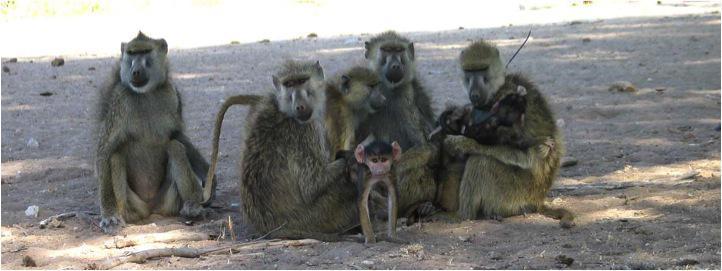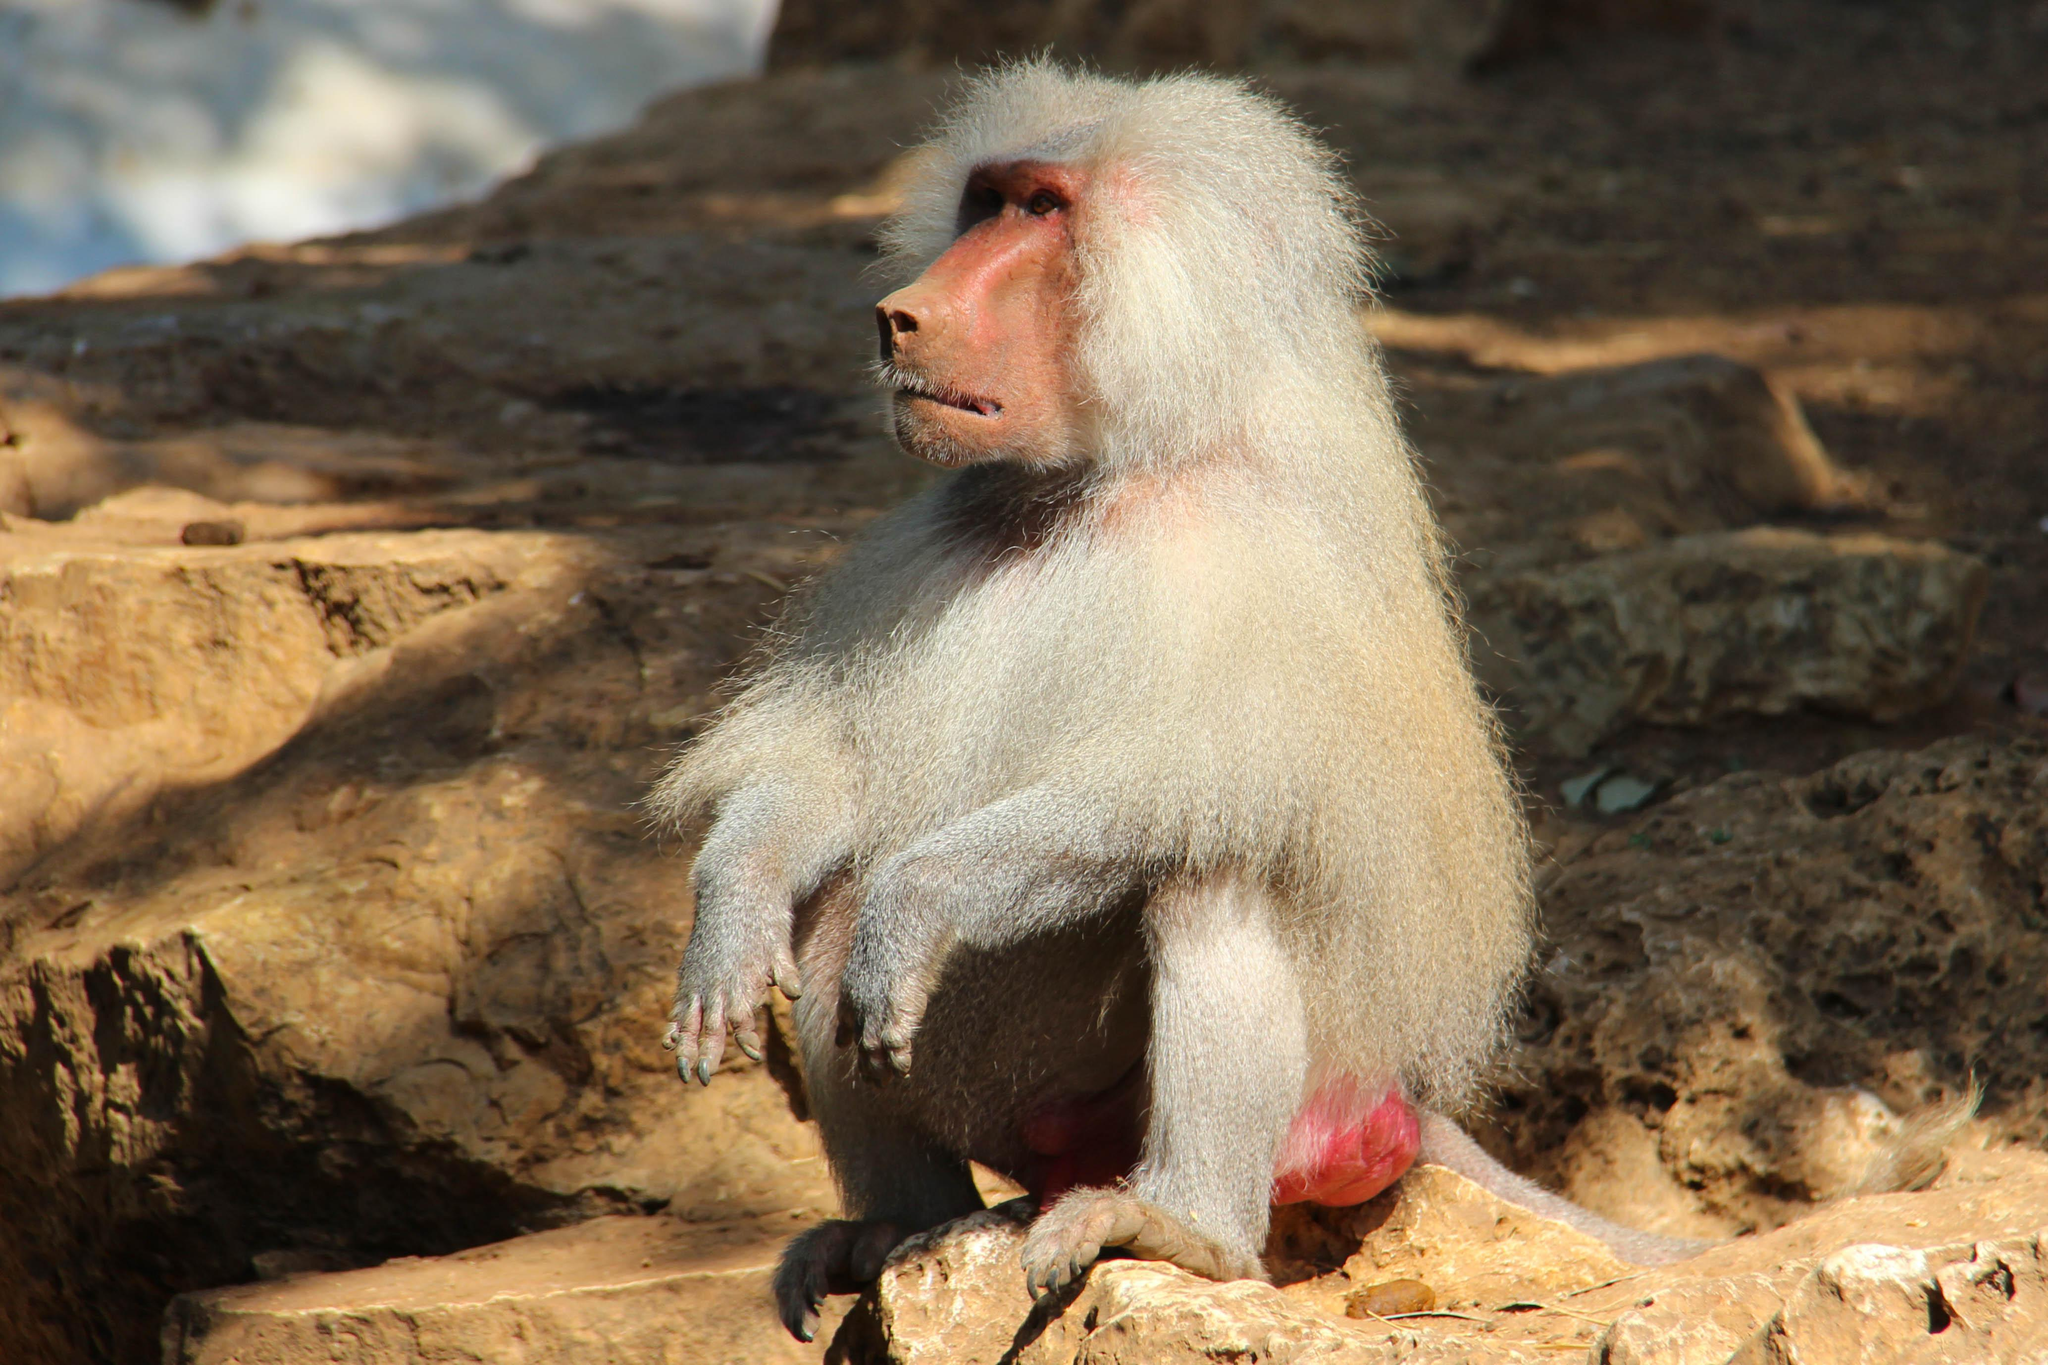The first image is the image on the left, the second image is the image on the right. Examine the images to the left and right. Is the description "The combined images include no more than ten baboons and include at least two baby baboons." accurate? Answer yes or no. Yes. 